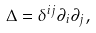<formula> <loc_0><loc_0><loc_500><loc_500>\Delta = \delta ^ { i j } \partial _ { i } \partial _ { j } ,</formula> 